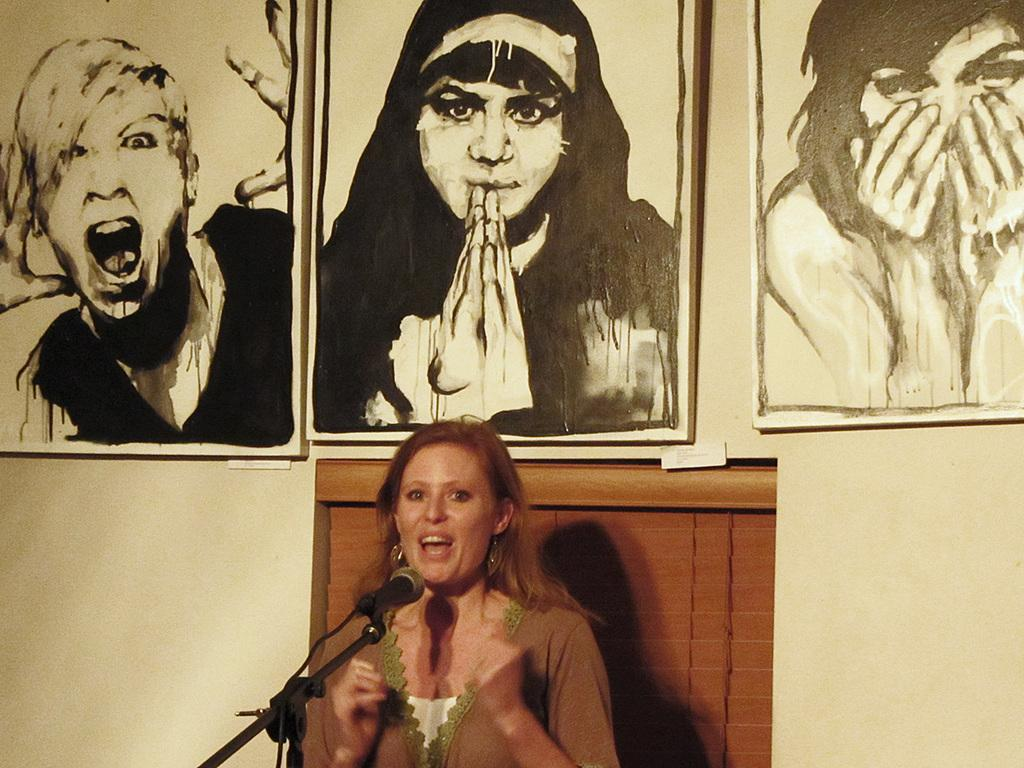Who is present in the image? There is a woman in the image. What is located behind the woman? There is a wall in the image. What can be seen on the wall? There are three paintings on the wall. How many minutes does it take for the box to fall off the wall in the image? There is no box present in the image, so it is not possible to answer that question. 